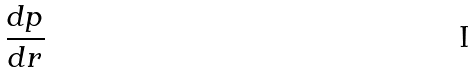<formula> <loc_0><loc_0><loc_500><loc_500>\frac { d p } { d r }</formula> 